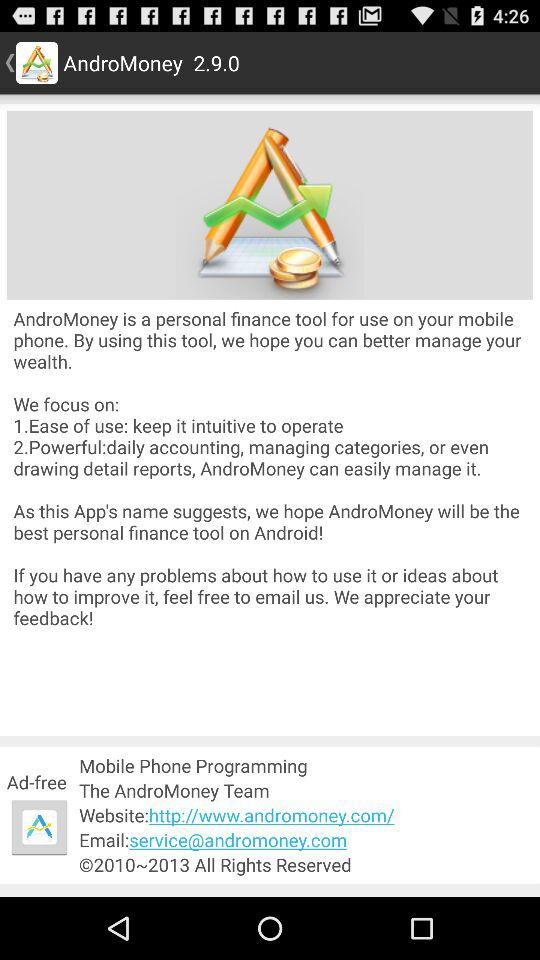What is the website of "AndroMoney"? The website is http://www.andromoney.com/. 